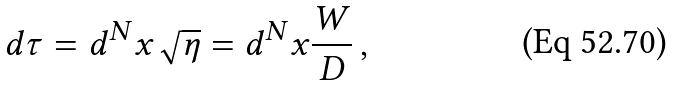Convert formula to latex. <formula><loc_0><loc_0><loc_500><loc_500>d \tau = d ^ { N } x \sqrt { \eta } = d ^ { N } x \frac { W } { D } \, ,</formula> 